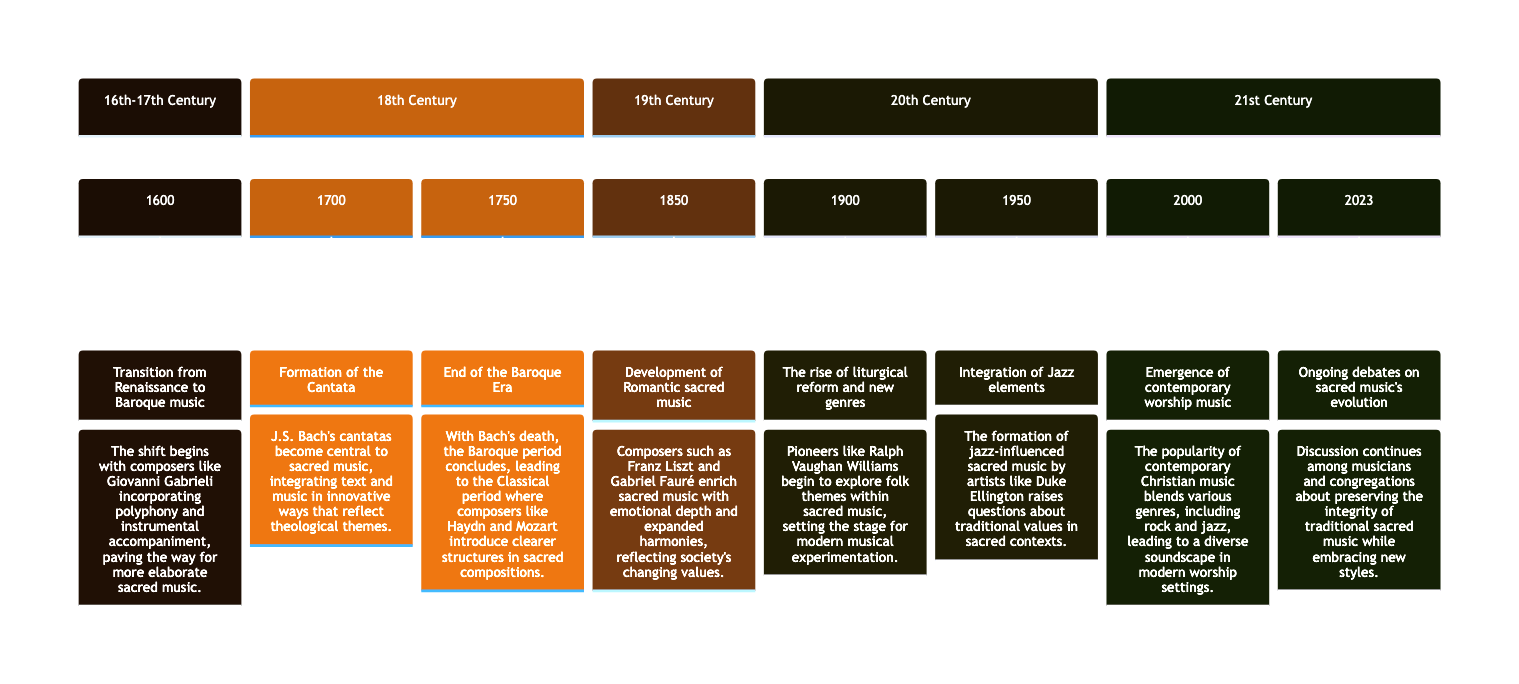What is the first event on the timeline? The timeline starts with the event labeled "Transition from Renaissance to Baroque music" in the year 1600.
Answer: Transition from Renaissance to Baroque music Who composed cantatas central to sacred music in 1700? The event in 1700 states that J.S. Bach's cantatas became central to sacred music during that time.
Answer: J.S. Bach What period concluded with Bach's death in 1750? The event in 1750 indicates that the Baroque period ended with Bach's death.
Answer: Baroque Era Which composer is associated with the development of Romantic sacred music in 1850? The event described in 1850 mentions composers such as Franz Liszt and Gabriel Fauré enriching sacred music, thus they are associated with this development.
Answer: Franz Liszt and Gabriel Fauré How many sections are there in the timeline diagram? Upon examining the timeline, there are five sections that represent different centuries of sacred music evolution.
Answer: Five What genre began to rise in 1900 according to the timeline? The timeline states that in 1900, the rise of liturgical reform and new genres, specifically mentioning folk themes, began to take place.
Answer: New genres What integration took place in 1950? The event of 1950 indicates that there was an integration of Jazz elements into sacred music, influenced by artists like Duke Ellington.
Answer: Jazz elements Which year marks the emergence of contemporary worship music? According to the timeline, the year 2000 marks the emergence of contemporary worship music.
Answer: 2000 What ongoing discussion is highlighted in 2023? The event in 2023 mentions ongoing debates about preserving the integrity of traditional sacred music while embracing new styles.
Answer: Preserving integrity 